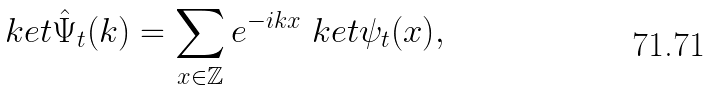Convert formula to latex. <formula><loc_0><loc_0><loc_500><loc_500>\ k e t { \hat { \Psi } _ { t } ( k ) } = \sum _ { x \in \mathbb { Z } } e ^ { - i k x } \ k e t { \psi _ { t } ( x ) } ,</formula> 